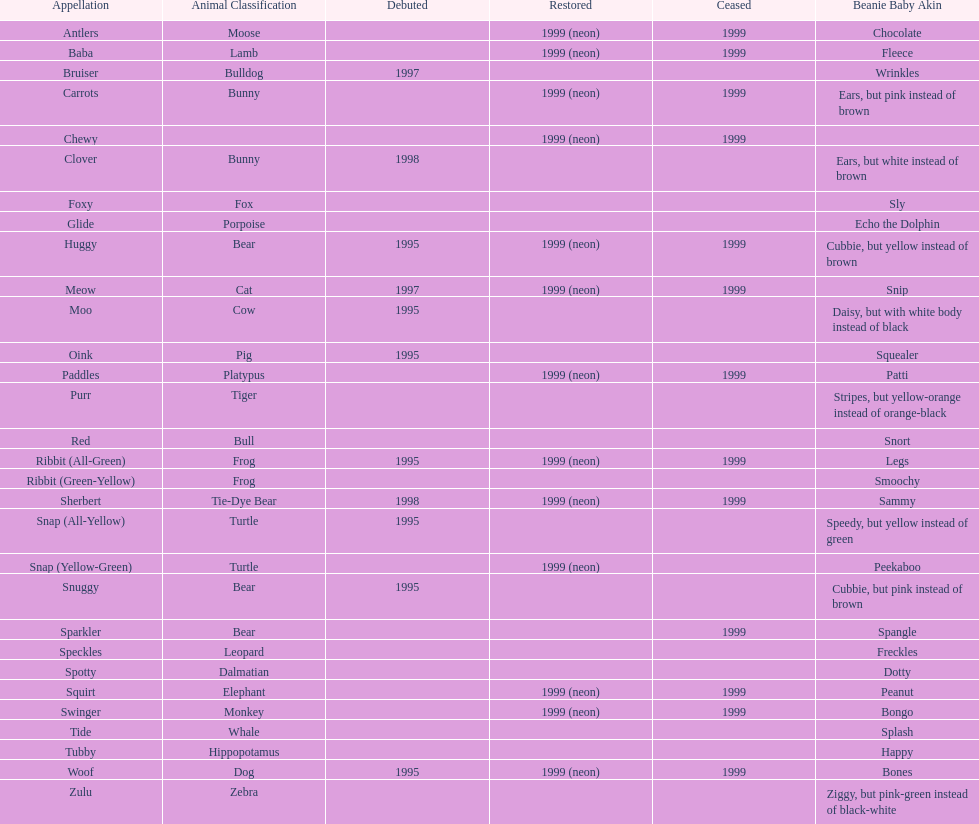What is the total number of pillow pals that were reintroduced as a neon variety? 13. 